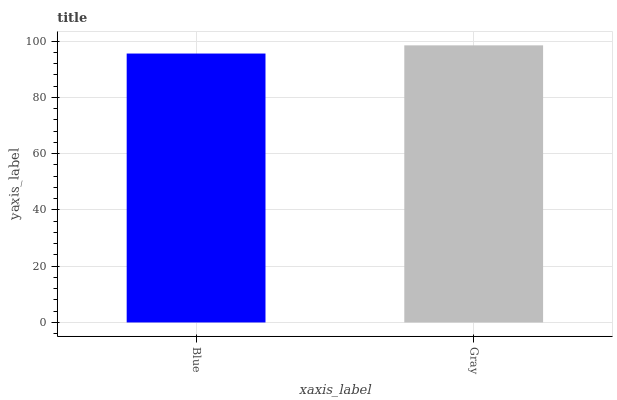Is Blue the minimum?
Answer yes or no. Yes. Is Gray the maximum?
Answer yes or no. Yes. Is Gray the minimum?
Answer yes or no. No. Is Gray greater than Blue?
Answer yes or no. Yes. Is Blue less than Gray?
Answer yes or no. Yes. Is Blue greater than Gray?
Answer yes or no. No. Is Gray less than Blue?
Answer yes or no. No. Is Gray the high median?
Answer yes or no. Yes. Is Blue the low median?
Answer yes or no. Yes. Is Blue the high median?
Answer yes or no. No. Is Gray the low median?
Answer yes or no. No. 